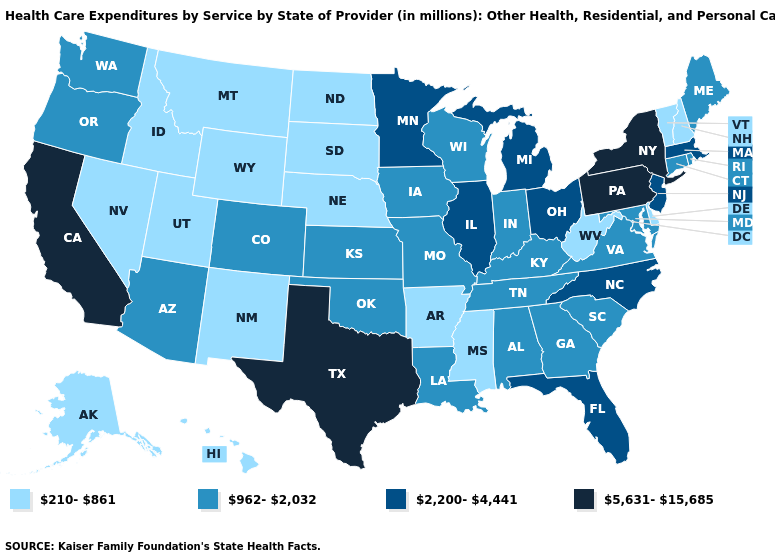Which states hav the highest value in the MidWest?
Keep it brief. Illinois, Michigan, Minnesota, Ohio. Which states hav the highest value in the West?
Concise answer only. California. Which states hav the highest value in the Northeast?
Answer briefly. New York, Pennsylvania. What is the value of Oregon?
Write a very short answer. 962-2,032. Does Delaware have the lowest value in the South?
Keep it brief. Yes. How many symbols are there in the legend?
Short answer required. 4. What is the highest value in states that border Rhode Island?
Write a very short answer. 2,200-4,441. What is the lowest value in states that border Montana?
Write a very short answer. 210-861. What is the lowest value in the MidWest?
Be succinct. 210-861. Does Kentucky have a higher value than Maine?
Concise answer only. No. Among the states that border Oregon , does Nevada have the lowest value?
Concise answer only. Yes. What is the value of Idaho?
Quick response, please. 210-861. How many symbols are there in the legend?
Keep it brief. 4. What is the lowest value in states that border South Dakota?
Keep it brief. 210-861. 